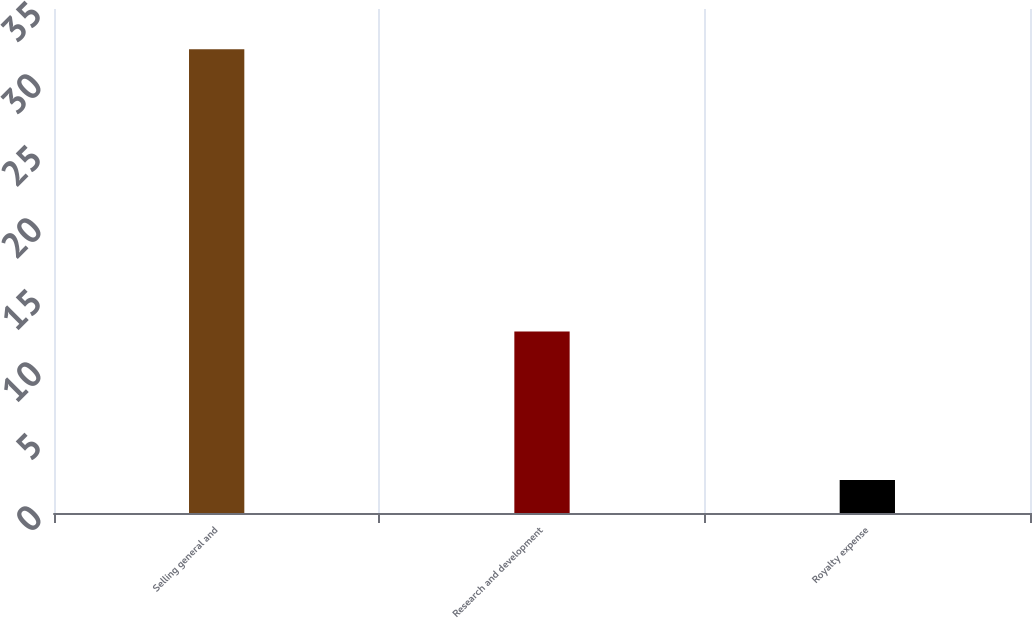Convert chart to OTSL. <chart><loc_0><loc_0><loc_500><loc_500><bar_chart><fcel>Selling general and<fcel>Research and development<fcel>Royalty expense<nl><fcel>32.2<fcel>12.6<fcel>2.3<nl></chart> 